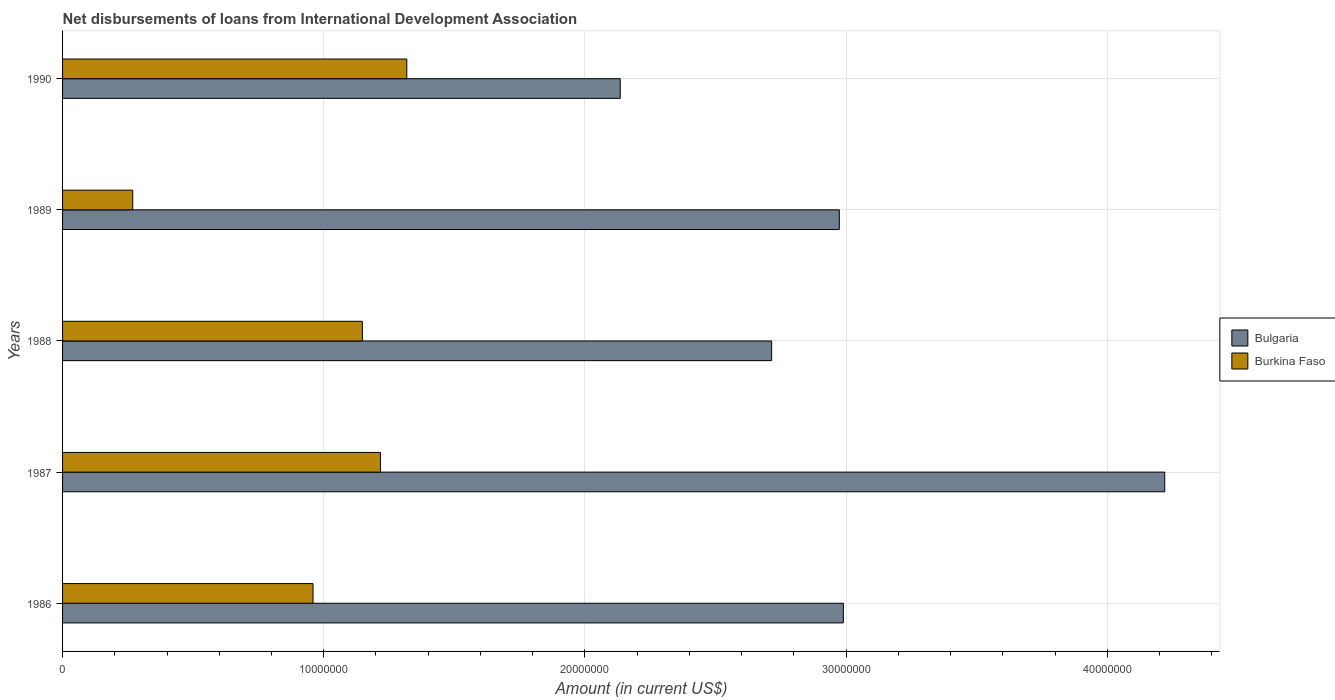How many different coloured bars are there?
Make the answer very short. 2. How many bars are there on the 2nd tick from the top?
Ensure brevity in your answer.  2. What is the label of the 4th group of bars from the top?
Keep it short and to the point. 1987. What is the amount of loans disbursed in Burkina Faso in 1990?
Your answer should be very brief. 1.32e+07. Across all years, what is the maximum amount of loans disbursed in Burkina Faso?
Ensure brevity in your answer.  1.32e+07. Across all years, what is the minimum amount of loans disbursed in Burkina Faso?
Your response must be concise. 2.69e+06. In which year was the amount of loans disbursed in Bulgaria maximum?
Your answer should be compact. 1987. What is the total amount of loans disbursed in Burkina Faso in the graph?
Your answer should be very brief. 4.91e+07. What is the difference between the amount of loans disbursed in Burkina Faso in 1987 and that in 1988?
Your answer should be compact. 6.91e+05. What is the difference between the amount of loans disbursed in Bulgaria in 1990 and the amount of loans disbursed in Burkina Faso in 1989?
Your answer should be compact. 1.87e+07. What is the average amount of loans disbursed in Burkina Faso per year?
Ensure brevity in your answer.  9.82e+06. In the year 1986, what is the difference between the amount of loans disbursed in Burkina Faso and amount of loans disbursed in Bulgaria?
Offer a terse response. -2.03e+07. In how many years, is the amount of loans disbursed in Burkina Faso greater than 8000000 US$?
Provide a succinct answer. 4. What is the ratio of the amount of loans disbursed in Bulgaria in 1987 to that in 1990?
Provide a succinct answer. 1.98. What is the difference between the highest and the second highest amount of loans disbursed in Burkina Faso?
Provide a short and direct response. 1.01e+06. What is the difference between the highest and the lowest amount of loans disbursed in Bulgaria?
Make the answer very short. 2.08e+07. In how many years, is the amount of loans disbursed in Burkina Faso greater than the average amount of loans disbursed in Burkina Faso taken over all years?
Provide a succinct answer. 3. What does the 2nd bar from the top in 1989 represents?
Offer a very short reply. Bulgaria. What does the 2nd bar from the bottom in 1988 represents?
Provide a succinct answer. Burkina Faso. Are the values on the major ticks of X-axis written in scientific E-notation?
Your answer should be compact. No. Does the graph contain grids?
Provide a short and direct response. Yes. How are the legend labels stacked?
Your answer should be compact. Vertical. What is the title of the graph?
Keep it short and to the point. Net disbursements of loans from International Development Association. Does "Tanzania" appear as one of the legend labels in the graph?
Make the answer very short. No. What is the label or title of the X-axis?
Ensure brevity in your answer.  Amount (in current US$). What is the Amount (in current US$) in Bulgaria in 1986?
Make the answer very short. 2.99e+07. What is the Amount (in current US$) of Burkina Faso in 1986?
Give a very brief answer. 9.59e+06. What is the Amount (in current US$) in Bulgaria in 1987?
Provide a succinct answer. 4.22e+07. What is the Amount (in current US$) in Burkina Faso in 1987?
Your answer should be compact. 1.22e+07. What is the Amount (in current US$) in Bulgaria in 1988?
Your answer should be very brief. 2.71e+07. What is the Amount (in current US$) of Burkina Faso in 1988?
Your answer should be very brief. 1.15e+07. What is the Amount (in current US$) in Bulgaria in 1989?
Offer a terse response. 2.97e+07. What is the Amount (in current US$) in Burkina Faso in 1989?
Give a very brief answer. 2.69e+06. What is the Amount (in current US$) of Bulgaria in 1990?
Ensure brevity in your answer.  2.14e+07. What is the Amount (in current US$) of Burkina Faso in 1990?
Provide a succinct answer. 1.32e+07. Across all years, what is the maximum Amount (in current US$) of Bulgaria?
Ensure brevity in your answer.  4.22e+07. Across all years, what is the maximum Amount (in current US$) of Burkina Faso?
Provide a succinct answer. 1.32e+07. Across all years, what is the minimum Amount (in current US$) in Bulgaria?
Your answer should be very brief. 2.14e+07. Across all years, what is the minimum Amount (in current US$) of Burkina Faso?
Make the answer very short. 2.69e+06. What is the total Amount (in current US$) of Bulgaria in the graph?
Make the answer very short. 1.50e+08. What is the total Amount (in current US$) of Burkina Faso in the graph?
Offer a terse response. 4.91e+07. What is the difference between the Amount (in current US$) of Bulgaria in 1986 and that in 1987?
Ensure brevity in your answer.  -1.23e+07. What is the difference between the Amount (in current US$) in Burkina Faso in 1986 and that in 1987?
Keep it short and to the point. -2.58e+06. What is the difference between the Amount (in current US$) in Bulgaria in 1986 and that in 1988?
Offer a terse response. 2.75e+06. What is the difference between the Amount (in current US$) in Burkina Faso in 1986 and that in 1988?
Your answer should be very brief. -1.89e+06. What is the difference between the Amount (in current US$) in Bulgaria in 1986 and that in 1989?
Provide a succinct answer. 1.54e+05. What is the difference between the Amount (in current US$) of Burkina Faso in 1986 and that in 1989?
Give a very brief answer. 6.90e+06. What is the difference between the Amount (in current US$) of Bulgaria in 1986 and that in 1990?
Offer a very short reply. 8.54e+06. What is the difference between the Amount (in current US$) in Burkina Faso in 1986 and that in 1990?
Ensure brevity in your answer.  -3.59e+06. What is the difference between the Amount (in current US$) of Bulgaria in 1987 and that in 1988?
Provide a short and direct response. 1.51e+07. What is the difference between the Amount (in current US$) of Burkina Faso in 1987 and that in 1988?
Your answer should be compact. 6.91e+05. What is the difference between the Amount (in current US$) in Bulgaria in 1987 and that in 1989?
Provide a short and direct response. 1.25e+07. What is the difference between the Amount (in current US$) in Burkina Faso in 1987 and that in 1989?
Your response must be concise. 9.48e+06. What is the difference between the Amount (in current US$) of Bulgaria in 1987 and that in 1990?
Your response must be concise. 2.08e+07. What is the difference between the Amount (in current US$) in Burkina Faso in 1987 and that in 1990?
Give a very brief answer. -1.01e+06. What is the difference between the Amount (in current US$) of Bulgaria in 1988 and that in 1989?
Provide a succinct answer. -2.59e+06. What is the difference between the Amount (in current US$) of Burkina Faso in 1988 and that in 1989?
Provide a short and direct response. 8.79e+06. What is the difference between the Amount (in current US$) of Bulgaria in 1988 and that in 1990?
Ensure brevity in your answer.  5.80e+06. What is the difference between the Amount (in current US$) of Burkina Faso in 1988 and that in 1990?
Provide a short and direct response. -1.70e+06. What is the difference between the Amount (in current US$) in Bulgaria in 1989 and that in 1990?
Your answer should be very brief. 8.39e+06. What is the difference between the Amount (in current US$) of Burkina Faso in 1989 and that in 1990?
Make the answer very short. -1.05e+07. What is the difference between the Amount (in current US$) in Bulgaria in 1986 and the Amount (in current US$) in Burkina Faso in 1987?
Offer a very short reply. 1.77e+07. What is the difference between the Amount (in current US$) of Bulgaria in 1986 and the Amount (in current US$) of Burkina Faso in 1988?
Give a very brief answer. 1.84e+07. What is the difference between the Amount (in current US$) in Bulgaria in 1986 and the Amount (in current US$) in Burkina Faso in 1989?
Make the answer very short. 2.72e+07. What is the difference between the Amount (in current US$) of Bulgaria in 1986 and the Amount (in current US$) of Burkina Faso in 1990?
Make the answer very short. 1.67e+07. What is the difference between the Amount (in current US$) in Bulgaria in 1987 and the Amount (in current US$) in Burkina Faso in 1988?
Keep it short and to the point. 3.07e+07. What is the difference between the Amount (in current US$) in Bulgaria in 1987 and the Amount (in current US$) in Burkina Faso in 1989?
Ensure brevity in your answer.  3.95e+07. What is the difference between the Amount (in current US$) of Bulgaria in 1987 and the Amount (in current US$) of Burkina Faso in 1990?
Offer a very short reply. 2.90e+07. What is the difference between the Amount (in current US$) in Bulgaria in 1988 and the Amount (in current US$) in Burkina Faso in 1989?
Your answer should be very brief. 2.45e+07. What is the difference between the Amount (in current US$) of Bulgaria in 1988 and the Amount (in current US$) of Burkina Faso in 1990?
Your response must be concise. 1.40e+07. What is the difference between the Amount (in current US$) of Bulgaria in 1989 and the Amount (in current US$) of Burkina Faso in 1990?
Provide a short and direct response. 1.66e+07. What is the average Amount (in current US$) of Bulgaria per year?
Give a very brief answer. 3.01e+07. What is the average Amount (in current US$) of Burkina Faso per year?
Your response must be concise. 9.82e+06. In the year 1986, what is the difference between the Amount (in current US$) of Bulgaria and Amount (in current US$) of Burkina Faso?
Give a very brief answer. 2.03e+07. In the year 1987, what is the difference between the Amount (in current US$) in Bulgaria and Amount (in current US$) in Burkina Faso?
Keep it short and to the point. 3.00e+07. In the year 1988, what is the difference between the Amount (in current US$) in Bulgaria and Amount (in current US$) in Burkina Faso?
Offer a terse response. 1.57e+07. In the year 1989, what is the difference between the Amount (in current US$) of Bulgaria and Amount (in current US$) of Burkina Faso?
Offer a very short reply. 2.71e+07. In the year 1990, what is the difference between the Amount (in current US$) in Bulgaria and Amount (in current US$) in Burkina Faso?
Provide a short and direct response. 8.17e+06. What is the ratio of the Amount (in current US$) in Bulgaria in 1986 to that in 1987?
Provide a succinct answer. 0.71. What is the ratio of the Amount (in current US$) of Burkina Faso in 1986 to that in 1987?
Your response must be concise. 0.79. What is the ratio of the Amount (in current US$) of Bulgaria in 1986 to that in 1988?
Make the answer very short. 1.1. What is the ratio of the Amount (in current US$) of Burkina Faso in 1986 to that in 1988?
Provide a succinct answer. 0.84. What is the ratio of the Amount (in current US$) of Bulgaria in 1986 to that in 1989?
Ensure brevity in your answer.  1.01. What is the ratio of the Amount (in current US$) in Burkina Faso in 1986 to that in 1989?
Offer a terse response. 3.57. What is the ratio of the Amount (in current US$) of Burkina Faso in 1986 to that in 1990?
Keep it short and to the point. 0.73. What is the ratio of the Amount (in current US$) in Bulgaria in 1987 to that in 1988?
Give a very brief answer. 1.55. What is the ratio of the Amount (in current US$) of Burkina Faso in 1987 to that in 1988?
Offer a very short reply. 1.06. What is the ratio of the Amount (in current US$) in Bulgaria in 1987 to that in 1989?
Your answer should be very brief. 1.42. What is the ratio of the Amount (in current US$) of Burkina Faso in 1987 to that in 1989?
Your answer should be very brief. 4.53. What is the ratio of the Amount (in current US$) of Bulgaria in 1987 to that in 1990?
Your answer should be compact. 1.98. What is the ratio of the Amount (in current US$) in Burkina Faso in 1987 to that in 1990?
Ensure brevity in your answer.  0.92. What is the ratio of the Amount (in current US$) in Bulgaria in 1988 to that in 1989?
Keep it short and to the point. 0.91. What is the ratio of the Amount (in current US$) of Burkina Faso in 1988 to that in 1989?
Keep it short and to the point. 4.27. What is the ratio of the Amount (in current US$) of Bulgaria in 1988 to that in 1990?
Make the answer very short. 1.27. What is the ratio of the Amount (in current US$) in Burkina Faso in 1988 to that in 1990?
Provide a short and direct response. 0.87. What is the ratio of the Amount (in current US$) in Bulgaria in 1989 to that in 1990?
Offer a very short reply. 1.39. What is the ratio of the Amount (in current US$) in Burkina Faso in 1989 to that in 1990?
Your answer should be very brief. 0.2. What is the difference between the highest and the second highest Amount (in current US$) in Bulgaria?
Give a very brief answer. 1.23e+07. What is the difference between the highest and the second highest Amount (in current US$) of Burkina Faso?
Keep it short and to the point. 1.01e+06. What is the difference between the highest and the lowest Amount (in current US$) in Bulgaria?
Provide a succinct answer. 2.08e+07. What is the difference between the highest and the lowest Amount (in current US$) in Burkina Faso?
Give a very brief answer. 1.05e+07. 